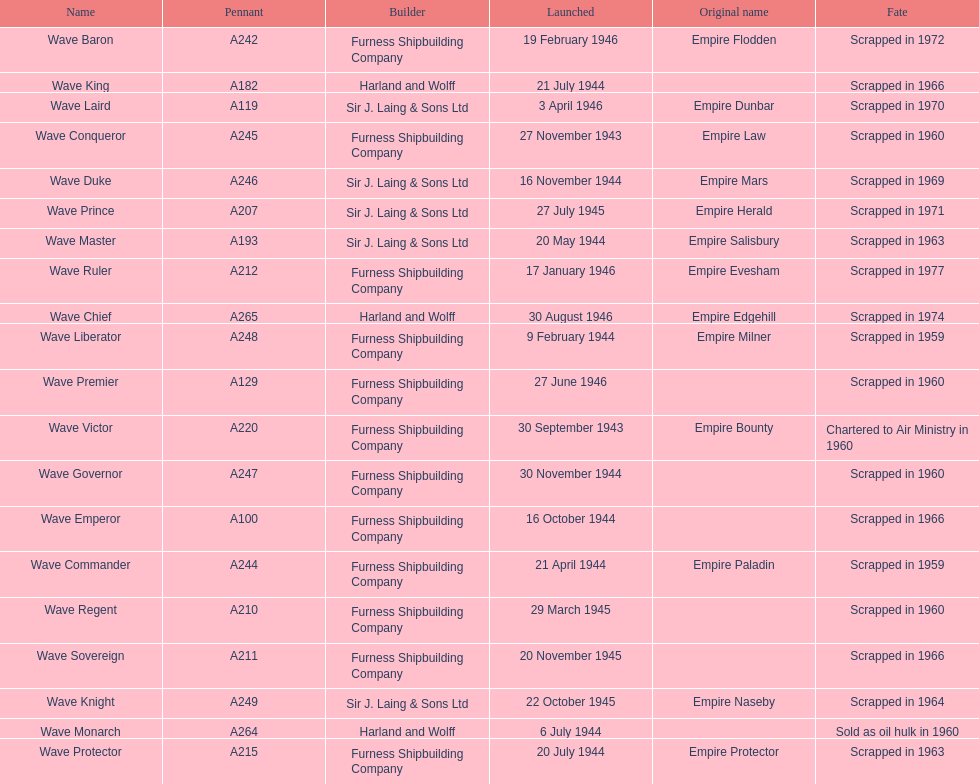What was the next wave class oiler after wave emperor? Wave Duke. 